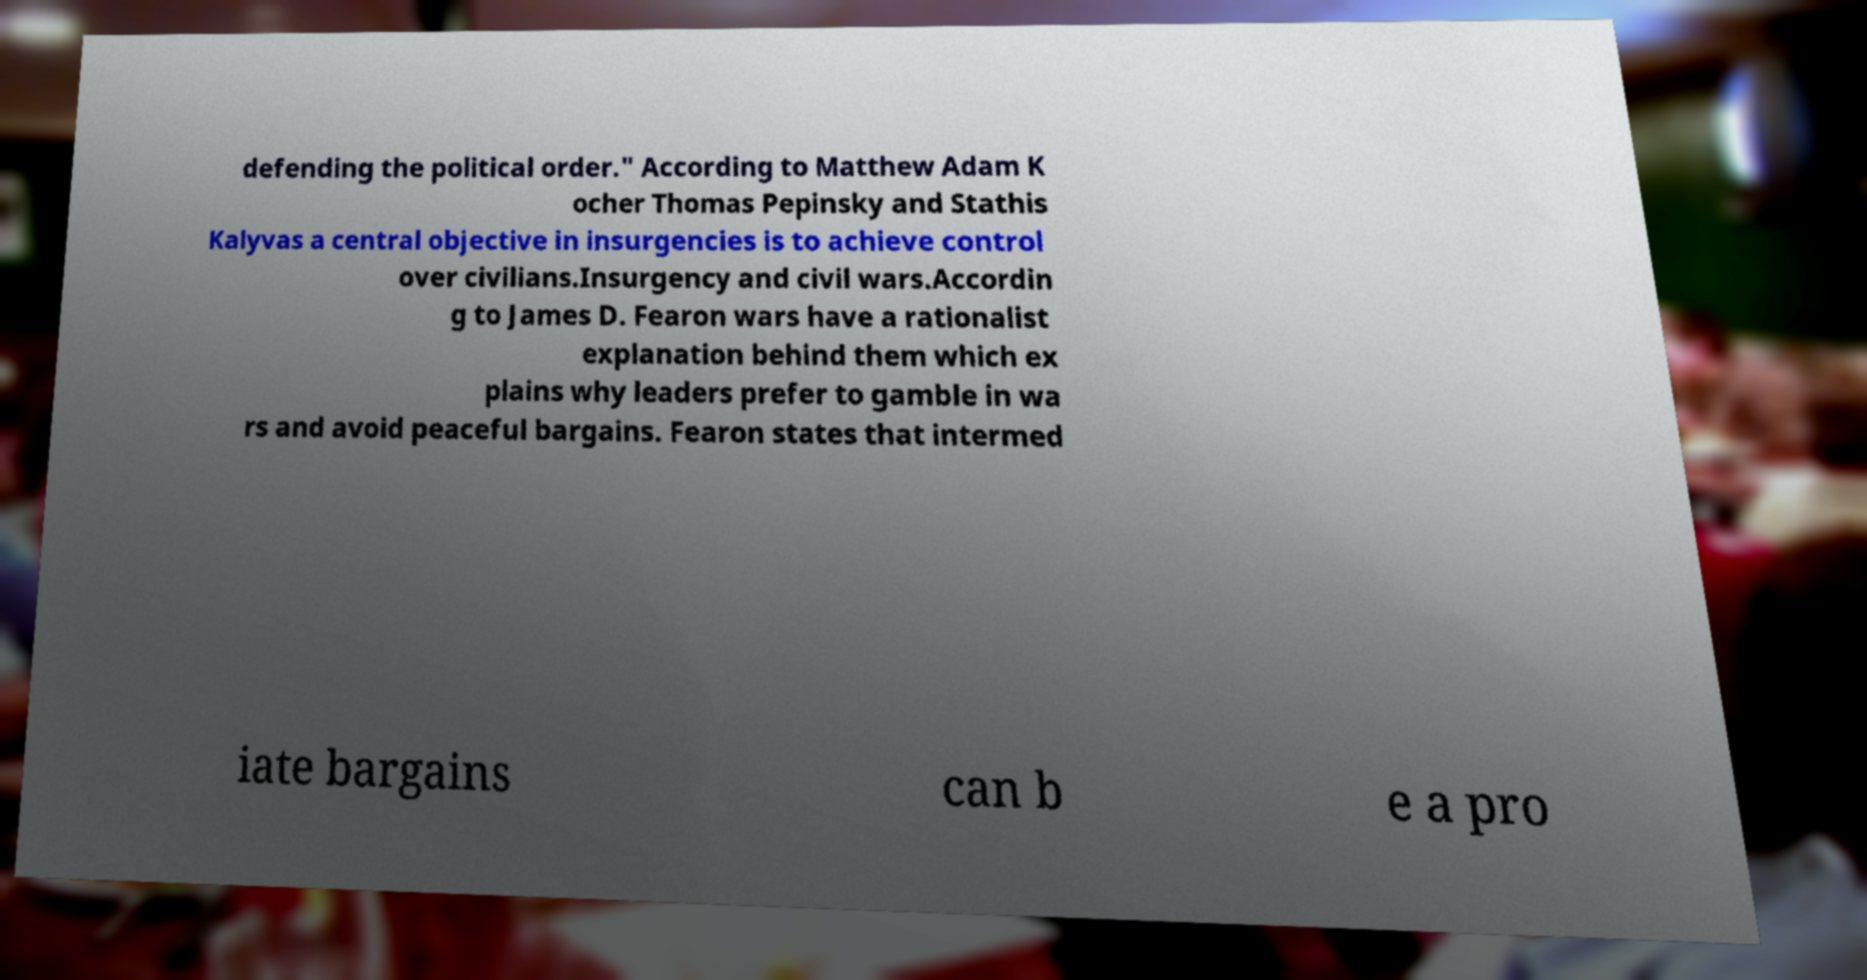I need the written content from this picture converted into text. Can you do that? defending the political order." According to Matthew Adam K ocher Thomas Pepinsky and Stathis Kalyvas a central objective in insurgencies is to achieve control over civilians.Insurgency and civil wars.Accordin g to James D. Fearon wars have a rationalist explanation behind them which ex plains why leaders prefer to gamble in wa rs and avoid peaceful bargains. Fearon states that intermed iate bargains can b e a pro 